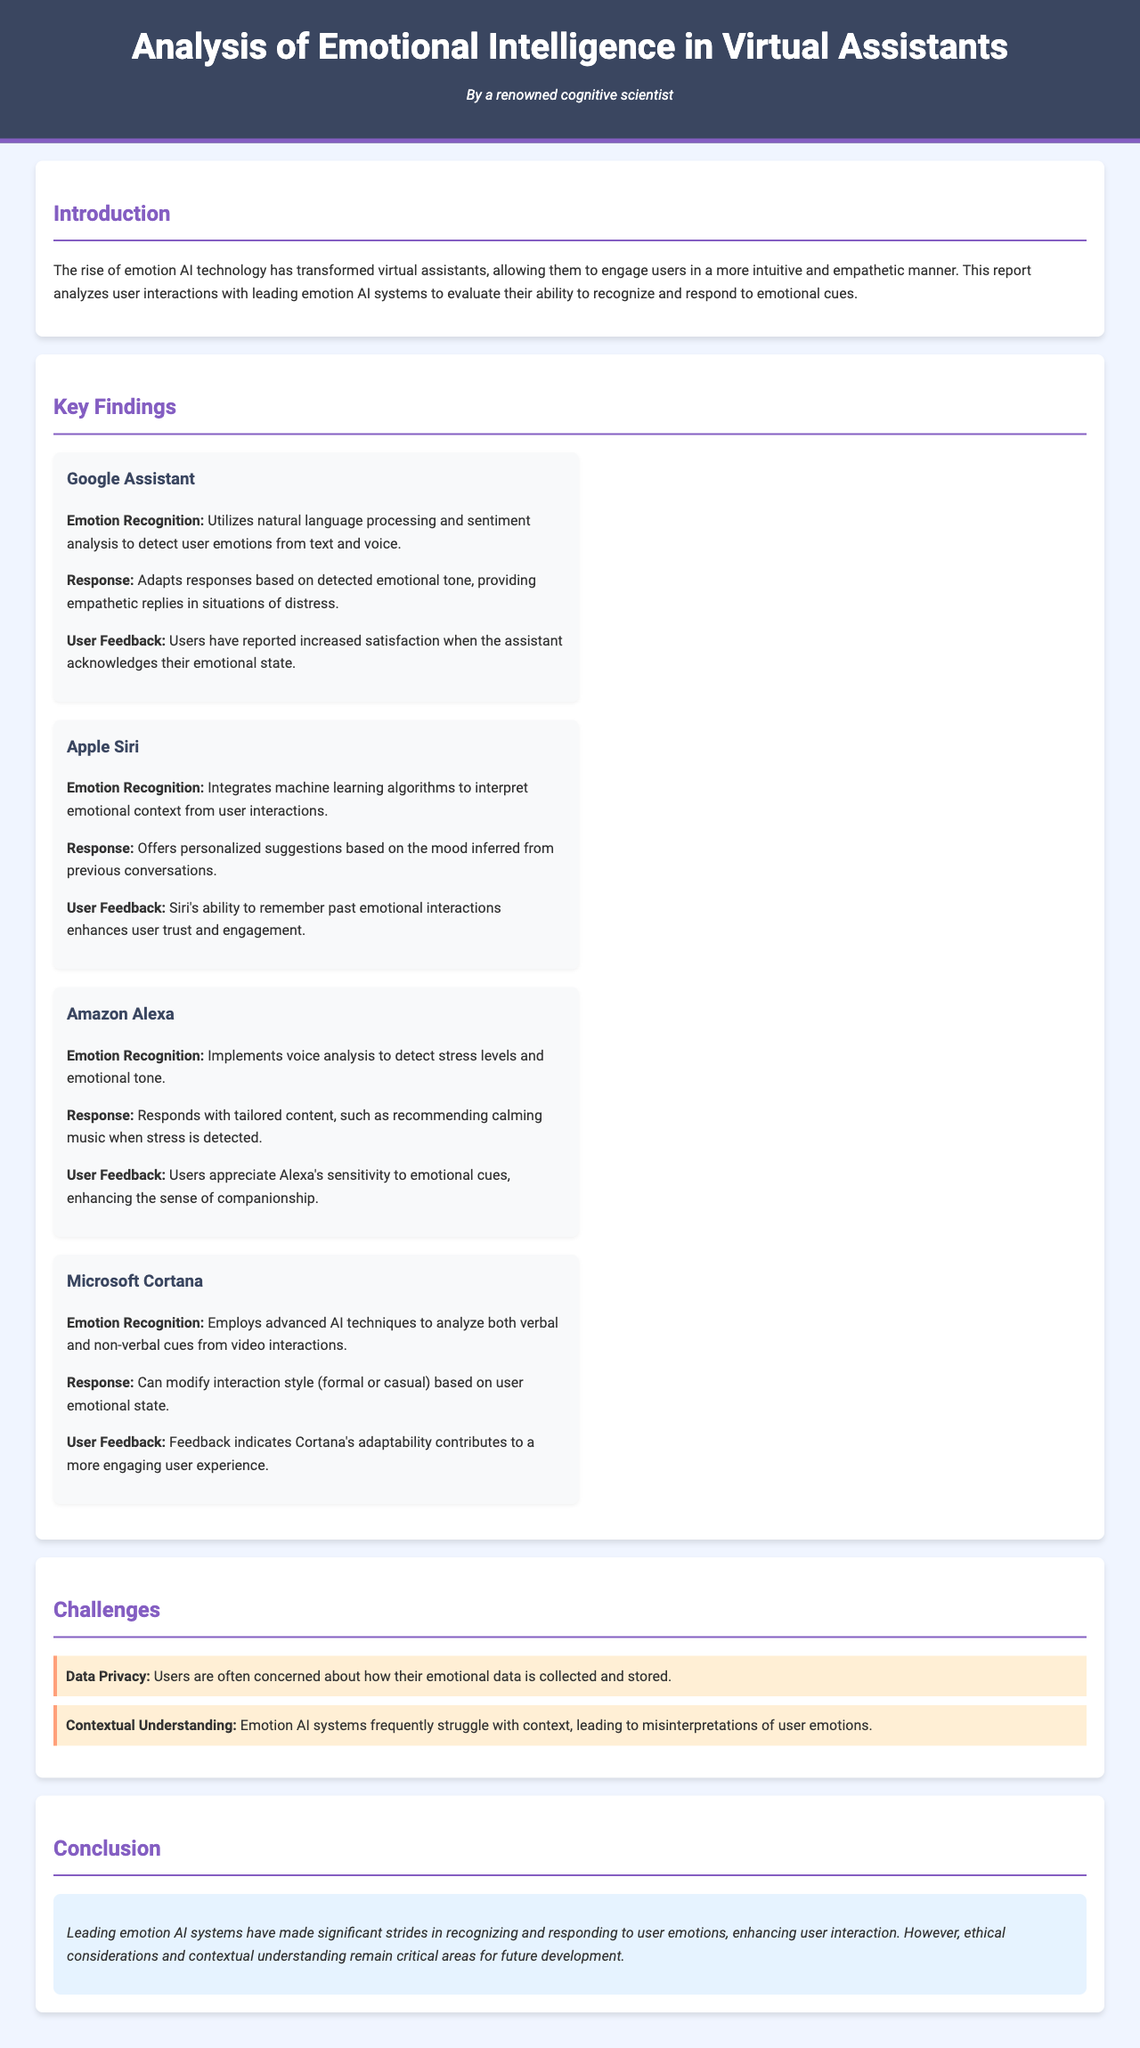What is the title of the report? The title of the report is prominently displayed in the header section.
Answer: Analysis of Emotional Intelligence in Virtual Assistants Who authored the report? The author's name is indicated under the title, attributing it to a famous cognitive scientist.
Answer: A renowned cognitive scientist Which virtual assistant uses natural language processing for emotion recognition? The section on key findings indicates which assistant utilizes this technology.
Answer: Google Assistant What is one challenge faced by emotion AI systems? The challenges are listed in a section specifically dedicated to them.
Answer: Data Privacy What type of response does Amazon Alexa provide when stress is detected? The response type is mentioned explicitly along with its context.
Answer: Recommending calming music What emotion recognition technique does Microsoft Cortana use? The report describes the techniques employed by different assistants, highlighting Cortana's methods.
Answer: Analyzes both verbal and non-verbal cues Which virtual assistant enhances user trust through remembering past emotional interactions? The document provides insights into user feedback for each assistant, pointing out specific strengths.
Answer: Apple Siri How do users feel about Google Assistant's emotional recognition capability? User feedback sections provide insights into how users perceive each assistant's emotional recognition abilities.
Answer: Increased satisfaction 